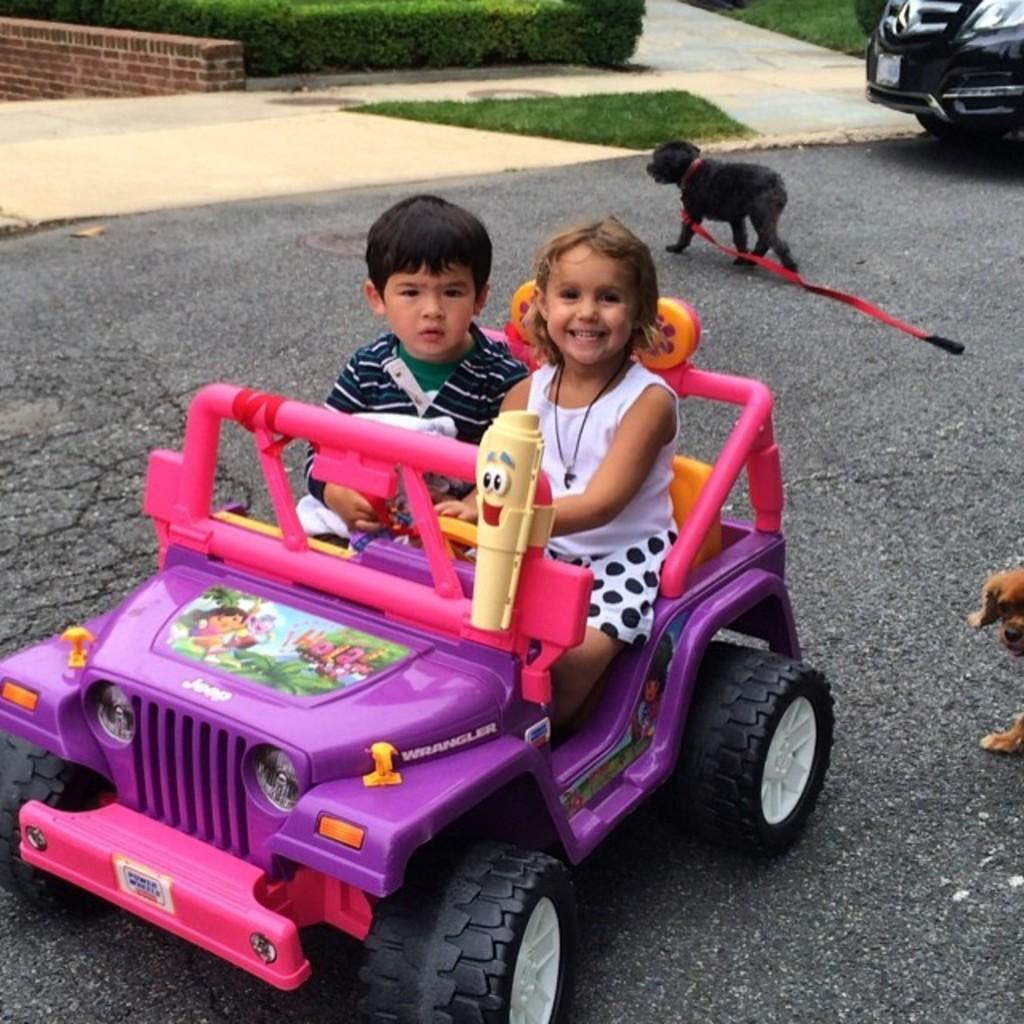What are the kids doing in the image? The kids are playing with a toy in the image. What can be seen in the background of the image? There is a road in the image. What type of animal is present in the image? There is a dog in the image. What type of vegetation is visible in the image? There are plants and grass in the image. What type of jeans is the farmer wearing in the image? There is no farmer present in the image, and therefore no one is wearing jeans. 